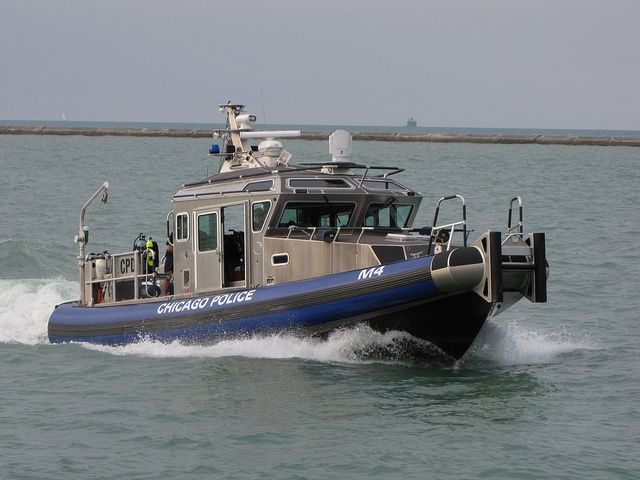Describe the objects in this image and their specific colors. I can see a boat in darkgray, black, and gray tones in this image. 